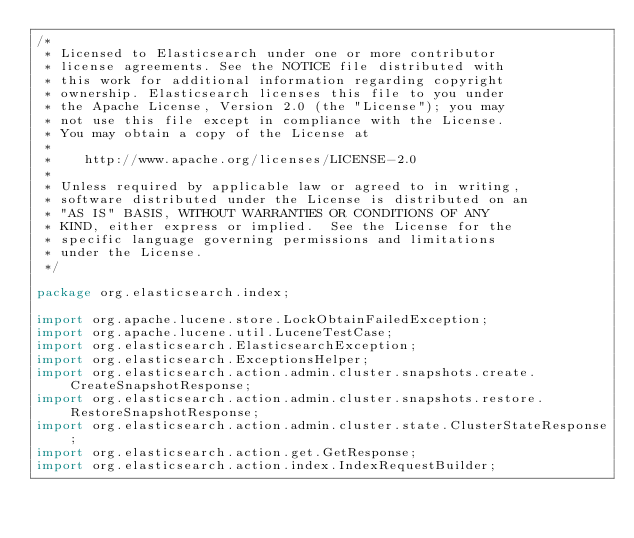<code> <loc_0><loc_0><loc_500><loc_500><_Java_>/*
 * Licensed to Elasticsearch under one or more contributor
 * license agreements. See the NOTICE file distributed with
 * this work for additional information regarding copyright
 * ownership. Elasticsearch licenses this file to you under
 * the Apache License, Version 2.0 (the "License"); you may
 * not use this file except in compliance with the License.
 * You may obtain a copy of the License at
 *
 *    http://www.apache.org/licenses/LICENSE-2.0
 *
 * Unless required by applicable law or agreed to in writing,
 * software distributed under the License is distributed on an
 * "AS IS" BASIS, WITHOUT WARRANTIES OR CONDITIONS OF ANY
 * KIND, either express or implied.  See the License for the
 * specific language governing permissions and limitations
 * under the License.
 */

package org.elasticsearch.index;

import org.apache.lucene.store.LockObtainFailedException;
import org.apache.lucene.util.LuceneTestCase;
import org.elasticsearch.ElasticsearchException;
import org.elasticsearch.ExceptionsHelper;
import org.elasticsearch.action.admin.cluster.snapshots.create.CreateSnapshotResponse;
import org.elasticsearch.action.admin.cluster.snapshots.restore.RestoreSnapshotResponse;
import org.elasticsearch.action.admin.cluster.state.ClusterStateResponse;
import org.elasticsearch.action.get.GetResponse;
import org.elasticsearch.action.index.IndexRequestBuilder;</code> 